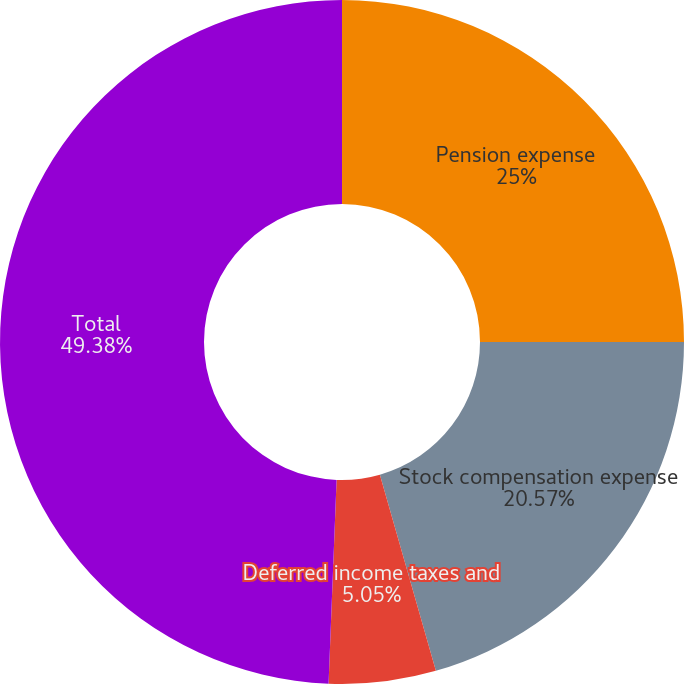Convert chart to OTSL. <chart><loc_0><loc_0><loc_500><loc_500><pie_chart><fcel>Pension expense<fcel>Stock compensation expense<fcel>Deferred income taxes and<fcel>Total<nl><fcel>25.0%<fcel>20.57%<fcel>5.05%<fcel>49.37%<nl></chart> 